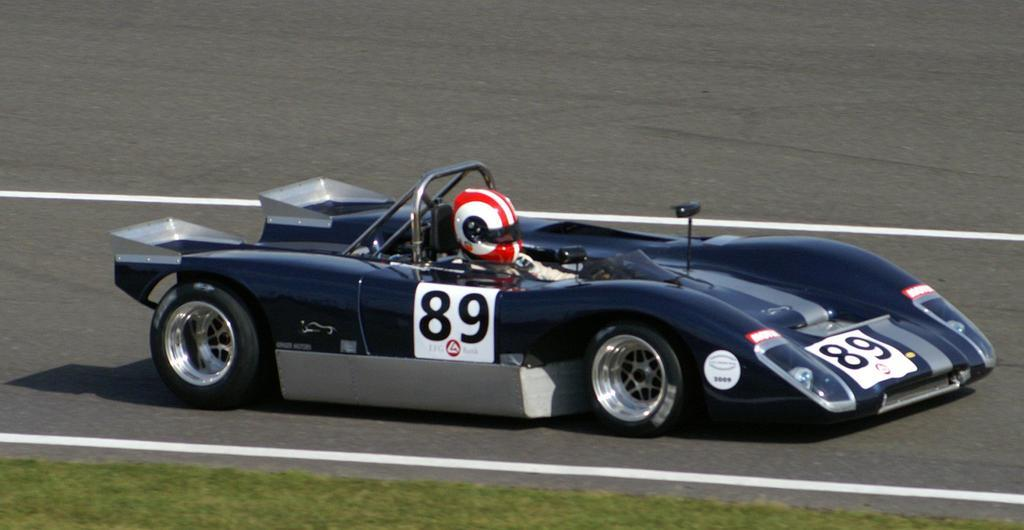Who is present in the image? There is a man in the image. What is the man wearing on his head? The man is wearing a red helmet. What is the man doing in the image? The man is driving a car. Where is the car located? The car is on the road. What can be seen on the sides of the road? There is green grass visible on the surface. What type of vacation is the man planning based on the image? There is no information about a vacation in the image; it simply shows a man driving a car. How many toes can be seen in the image? There are no visible toes in the image. 